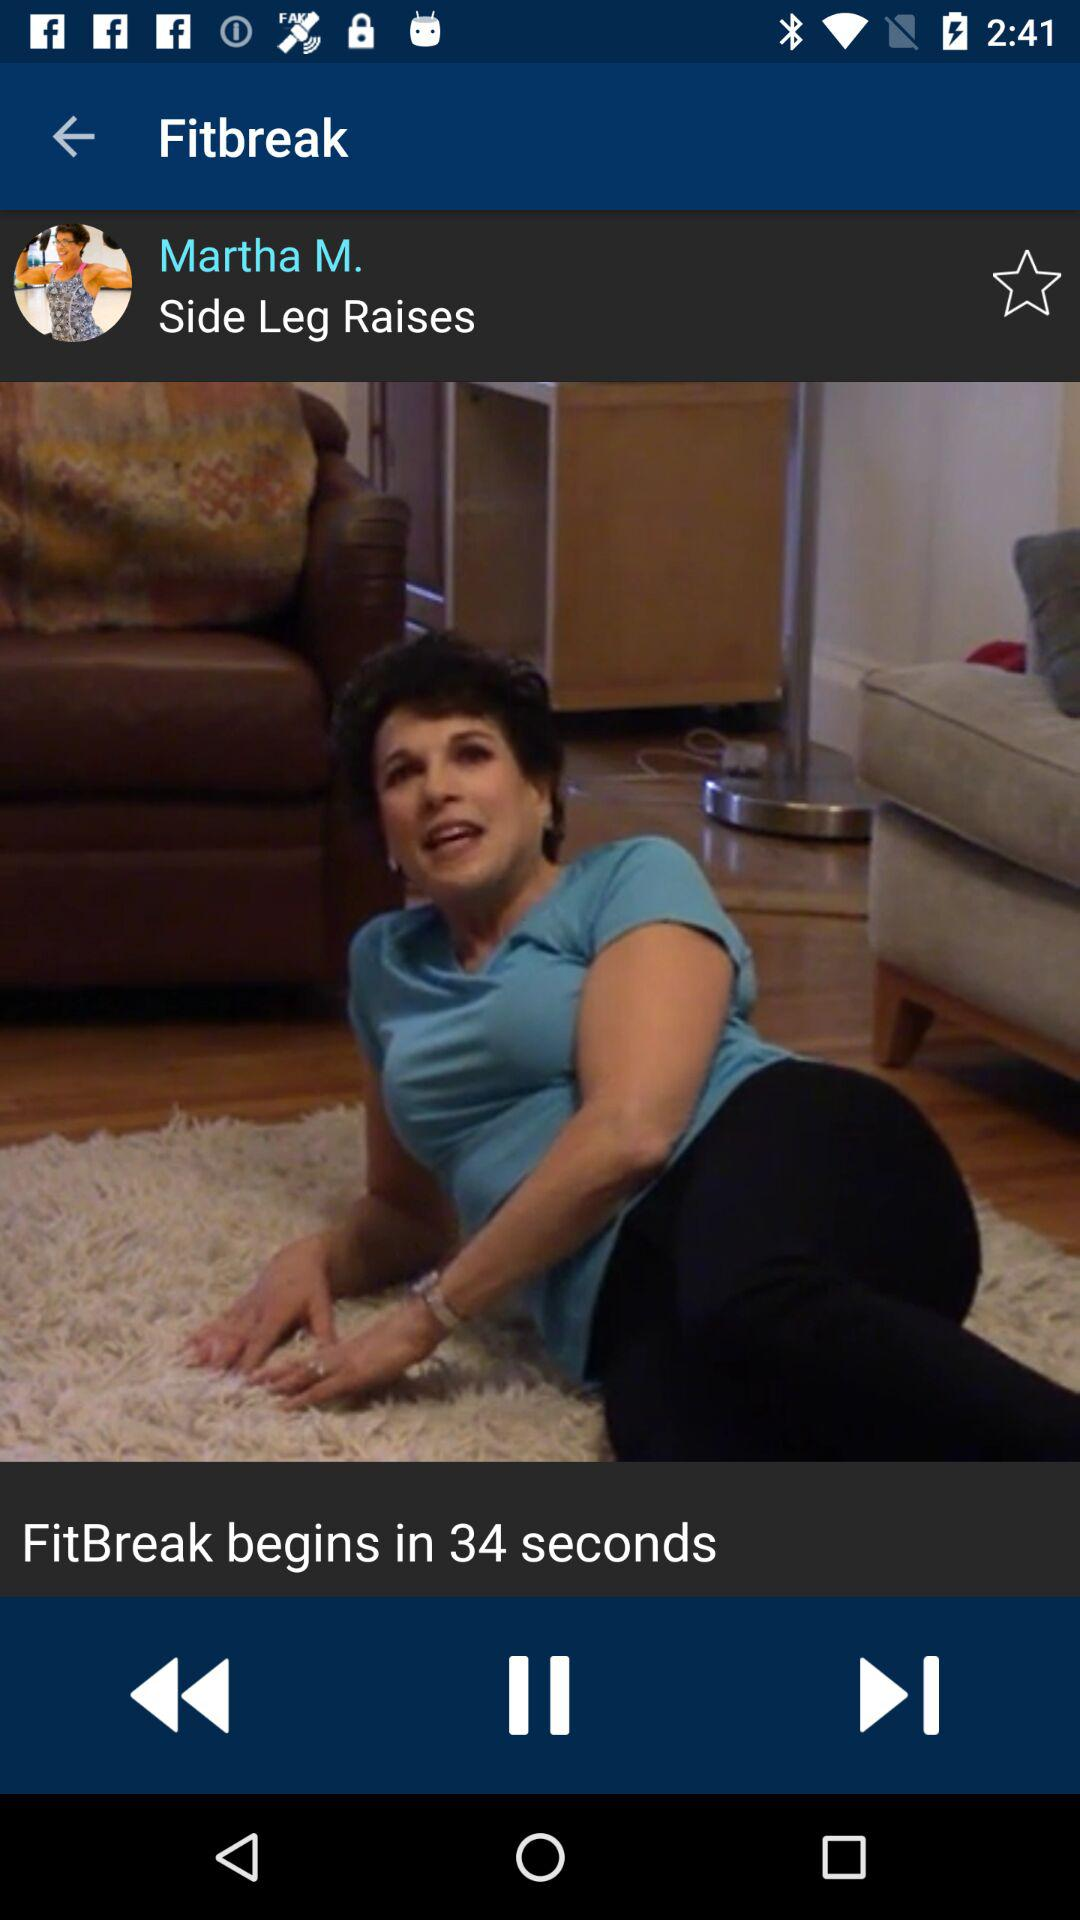What is the user name? The user name is Martha M. 